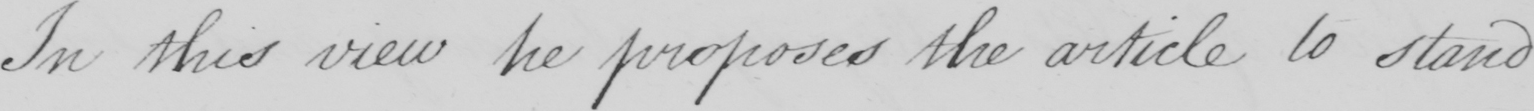Can you tell me what this handwritten text says? In this view he proposes the article to stand 